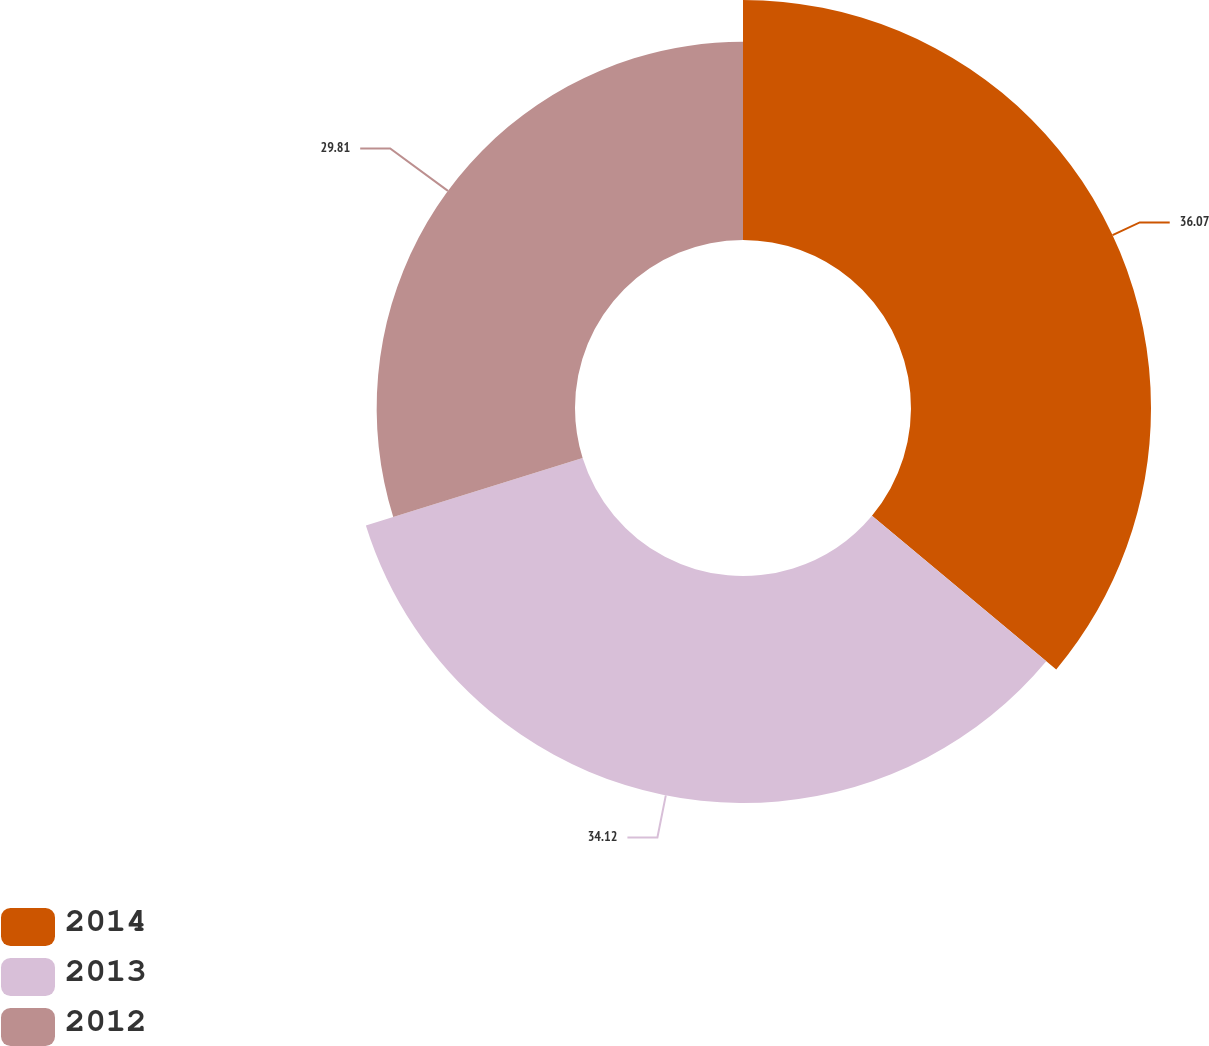<chart> <loc_0><loc_0><loc_500><loc_500><pie_chart><fcel>2014<fcel>2013<fcel>2012<nl><fcel>36.07%<fcel>34.12%<fcel>29.81%<nl></chart> 